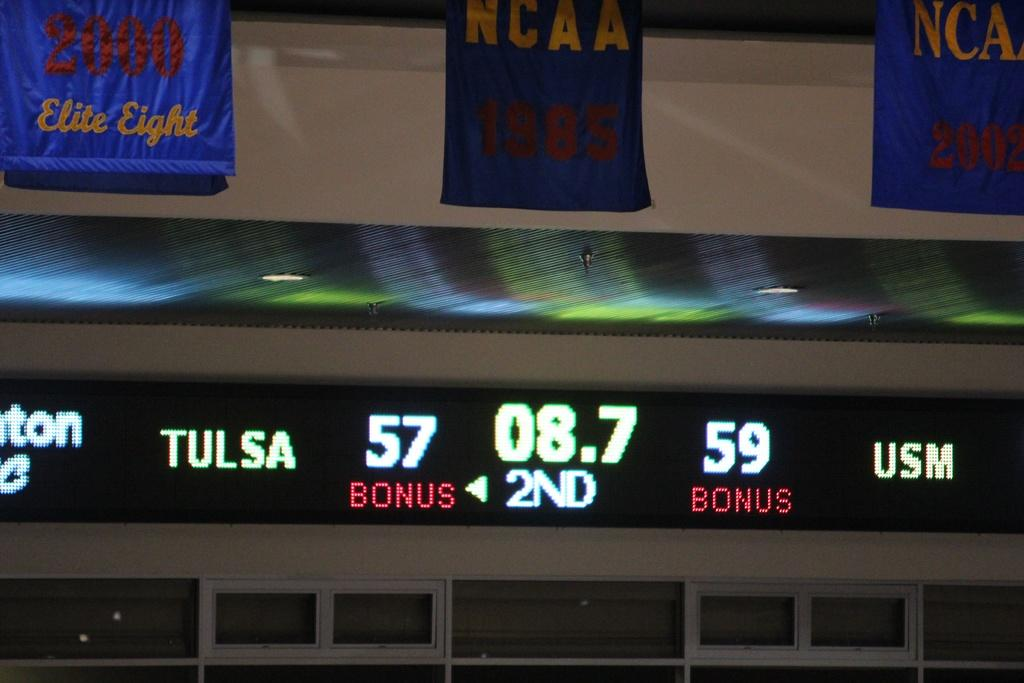<image>
Relay a brief, clear account of the picture shown. A scoreboard showing the scare between Tulsa and USM. 